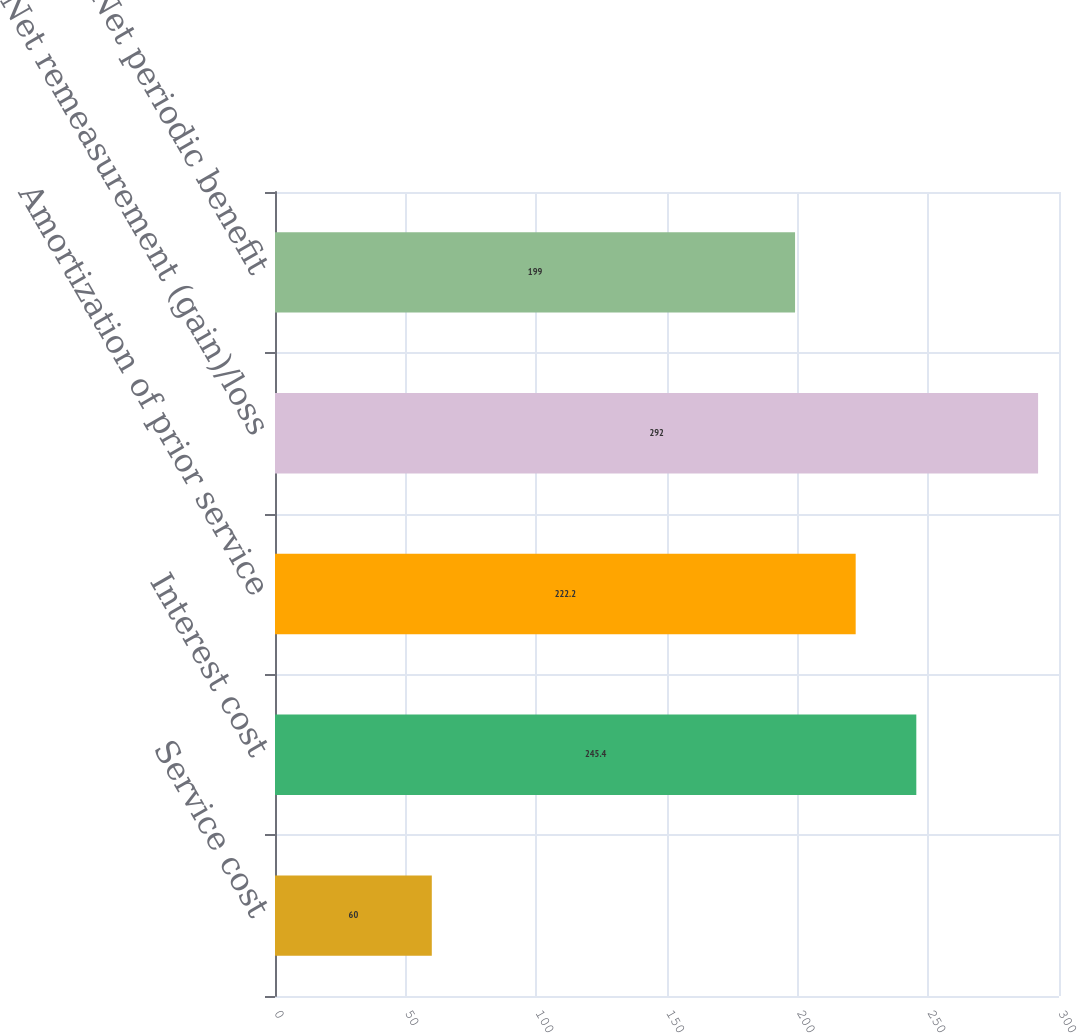<chart> <loc_0><loc_0><loc_500><loc_500><bar_chart><fcel>Service cost<fcel>Interest cost<fcel>Amortization of prior service<fcel>Net remeasurement (gain)/loss<fcel>Net periodic benefit<nl><fcel>60<fcel>245.4<fcel>222.2<fcel>292<fcel>199<nl></chart> 